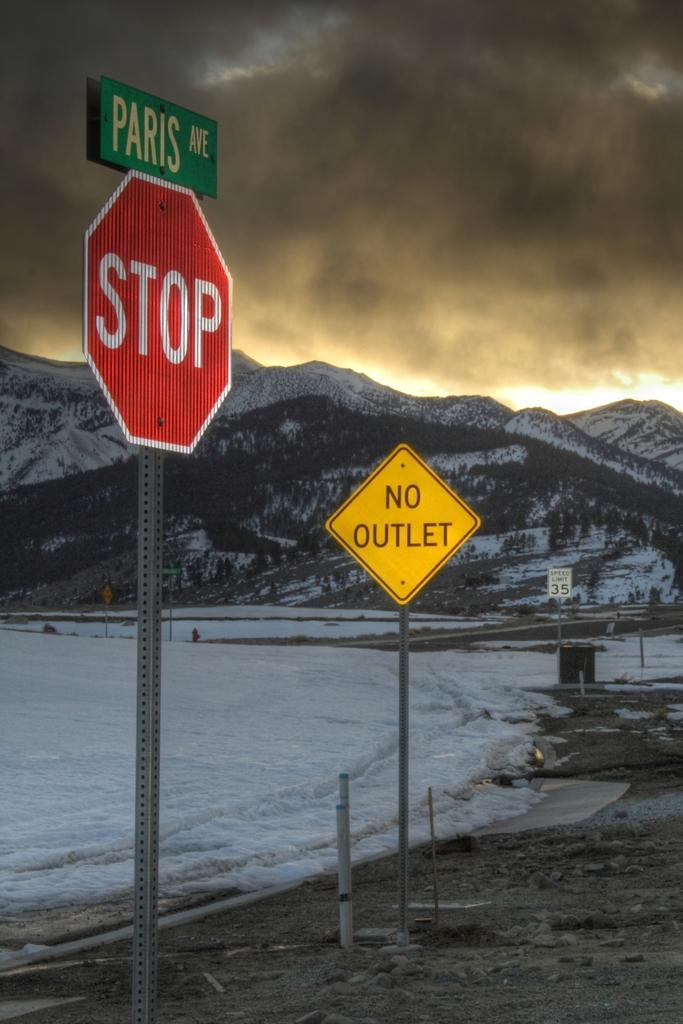Provide a one-sentence caption for the provided image. A mountain with a stop sign and No Outlet sign in the foreground. 